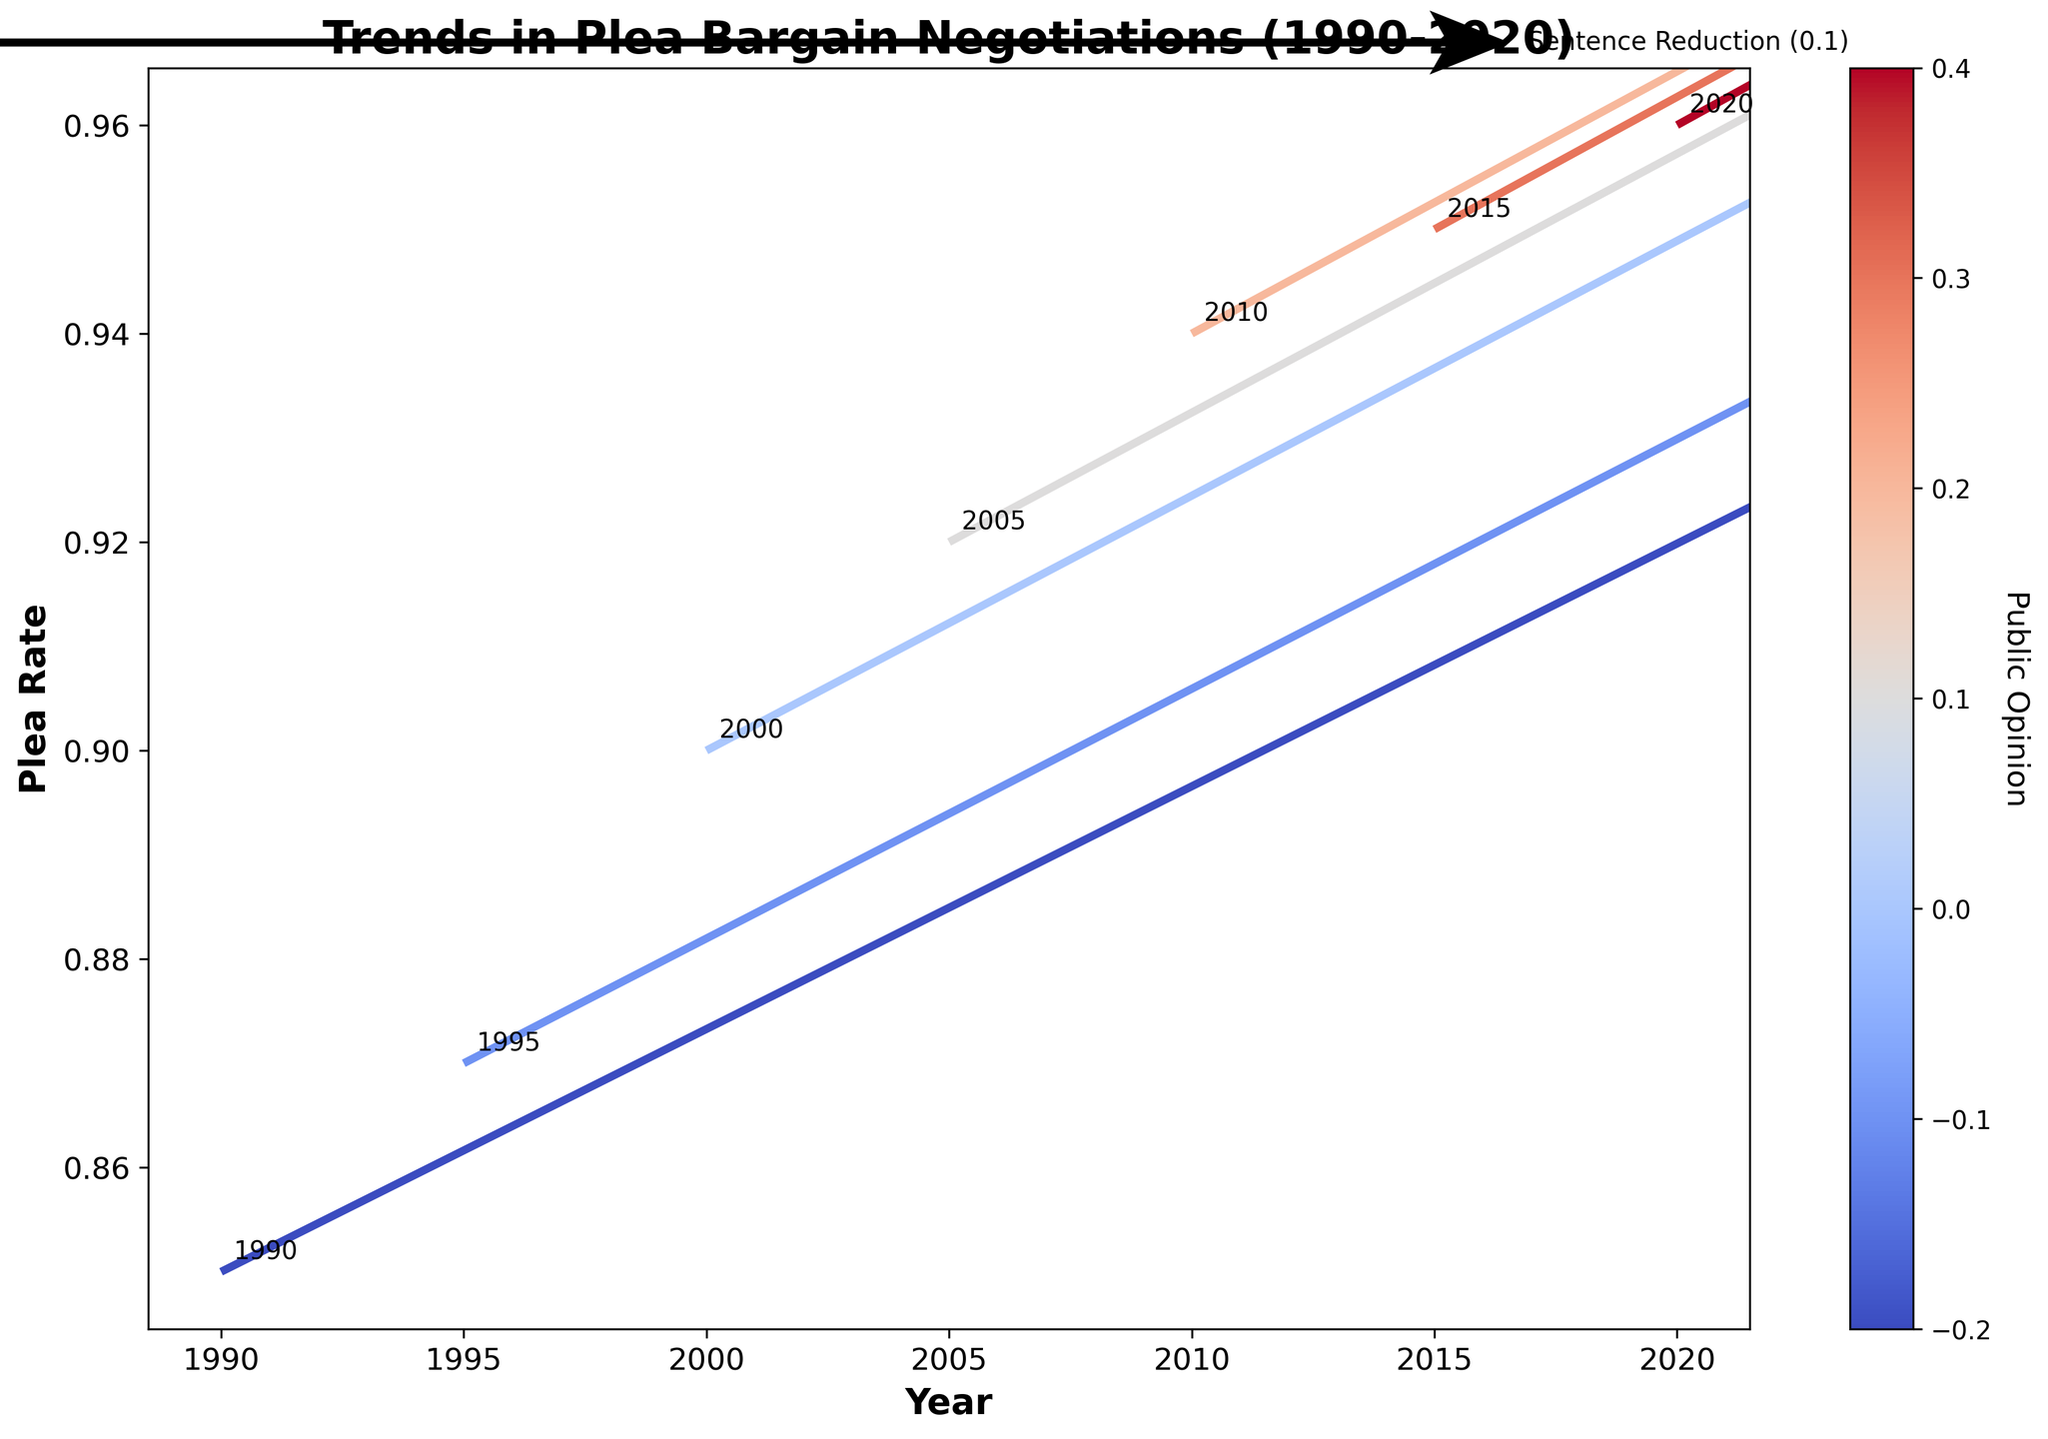What's the title of the figure? The title of the figure is displayed at the top in bold and larger font size as compared to other texts in the plot.
Answer: Trends in Plea Bargain Negotiations (1990-2020) What does the color of the arrows represent in the plot? The color of the arrows represents the public opinion, as indicated by the colorbar on the right side of the figure.
Answer: Public Opinion How many data points are represented in the plot? By looking at the number of arrows and year annotations, there are a total of 7 data points, one for each specified year from 1990 to 2020.
Answer: 7 Which year shows the highest plea rate? By checking the vertical position of the arrows on the y-axis, the plea rate is highest in 2020.
Answer: 2020 How has the plea rate changed over the three decades from 1990 to 2020? By observing the upward progression of arrowheads over the years on the y-axis, the plea rate has steadily increased.
Answer: Increased What's the average sentence reduction value over the three decades? The sentence reduction values over the years are 0.3, 0.35, 0.4, 0.45, 0.5, 0.55, and 0.6. Sum these values (3.15) and divide by 7 (number of years).
Answer: 0.45 Which year has the steepest arrow indicating a significant change in plea rate and prosecutor caseload? The steepness of an arrow is determined by the magnitude of its components (vertical and horizontal). The most vertical arrow due to caseload and plea rate increase seems to be in 2020.
Answer: 2020 How has public opinion changed from 1990 to 2020? The color transition of arrows from darker shades (negative opinion) to lighter shades (positive opinion) indicates that public opinion has become more favorable over time.
Answer: More favorable When was the prosecutor caseload at its lowest? The smallest vertical component of the arrows corresponding to prosecutor caseload occurs in 1990.
Answer: 1990 